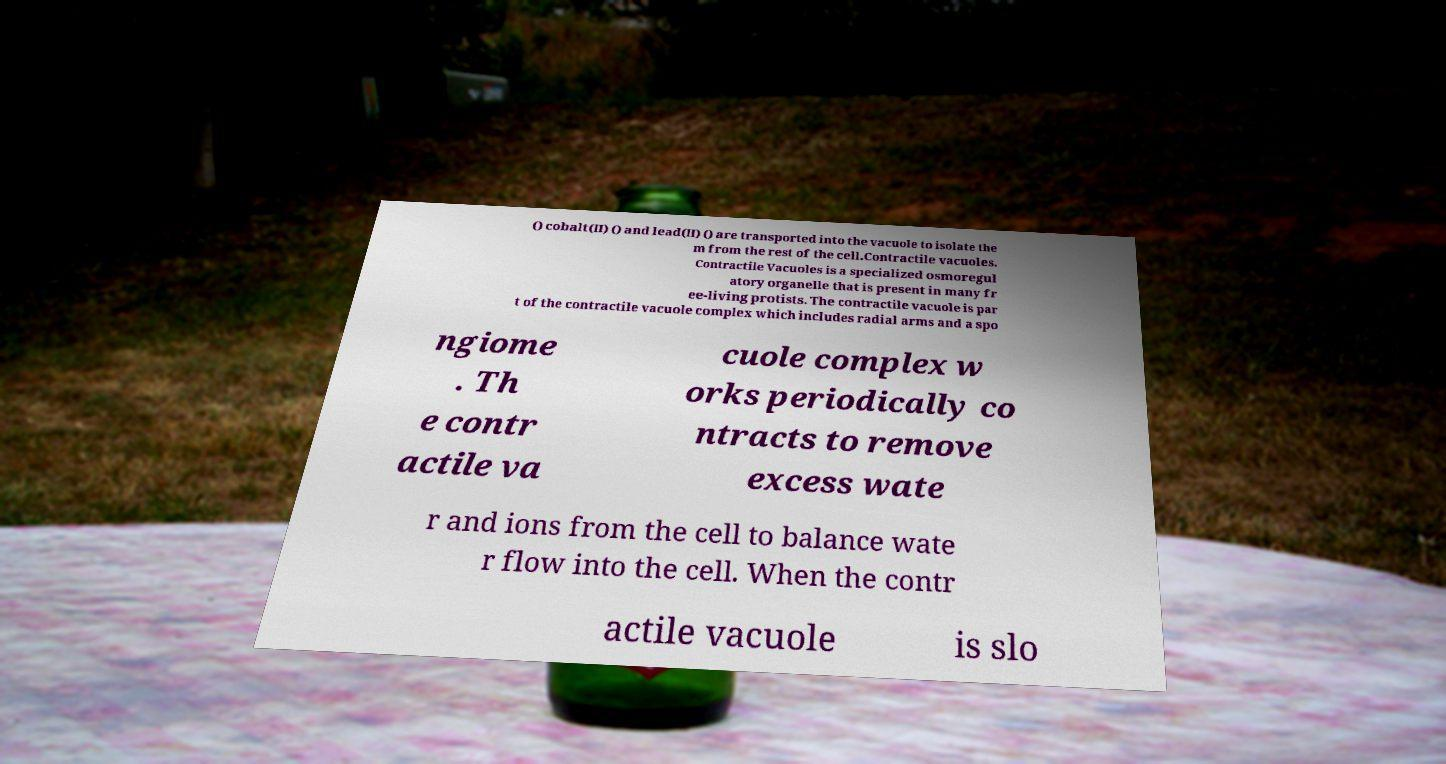Please identify and transcribe the text found in this image. () cobalt(II) () and lead(II) () are transported into the vacuole to isolate the m from the rest of the cell.Contractile vacuoles. Contractile Vacuoles is a specialized osmoregul atory organelle that is present in many fr ee-living protists. The contractile vacuole is par t of the contractile vacuole complex which includes radial arms and a spo ngiome . Th e contr actile va cuole complex w orks periodically co ntracts to remove excess wate r and ions from the cell to balance wate r flow into the cell. When the contr actile vacuole is slo 